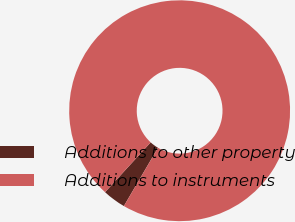<chart> <loc_0><loc_0><loc_500><loc_500><pie_chart><fcel>Additions to other property<fcel>Additions to instruments<nl><fcel>3.38%<fcel>96.62%<nl></chart> 